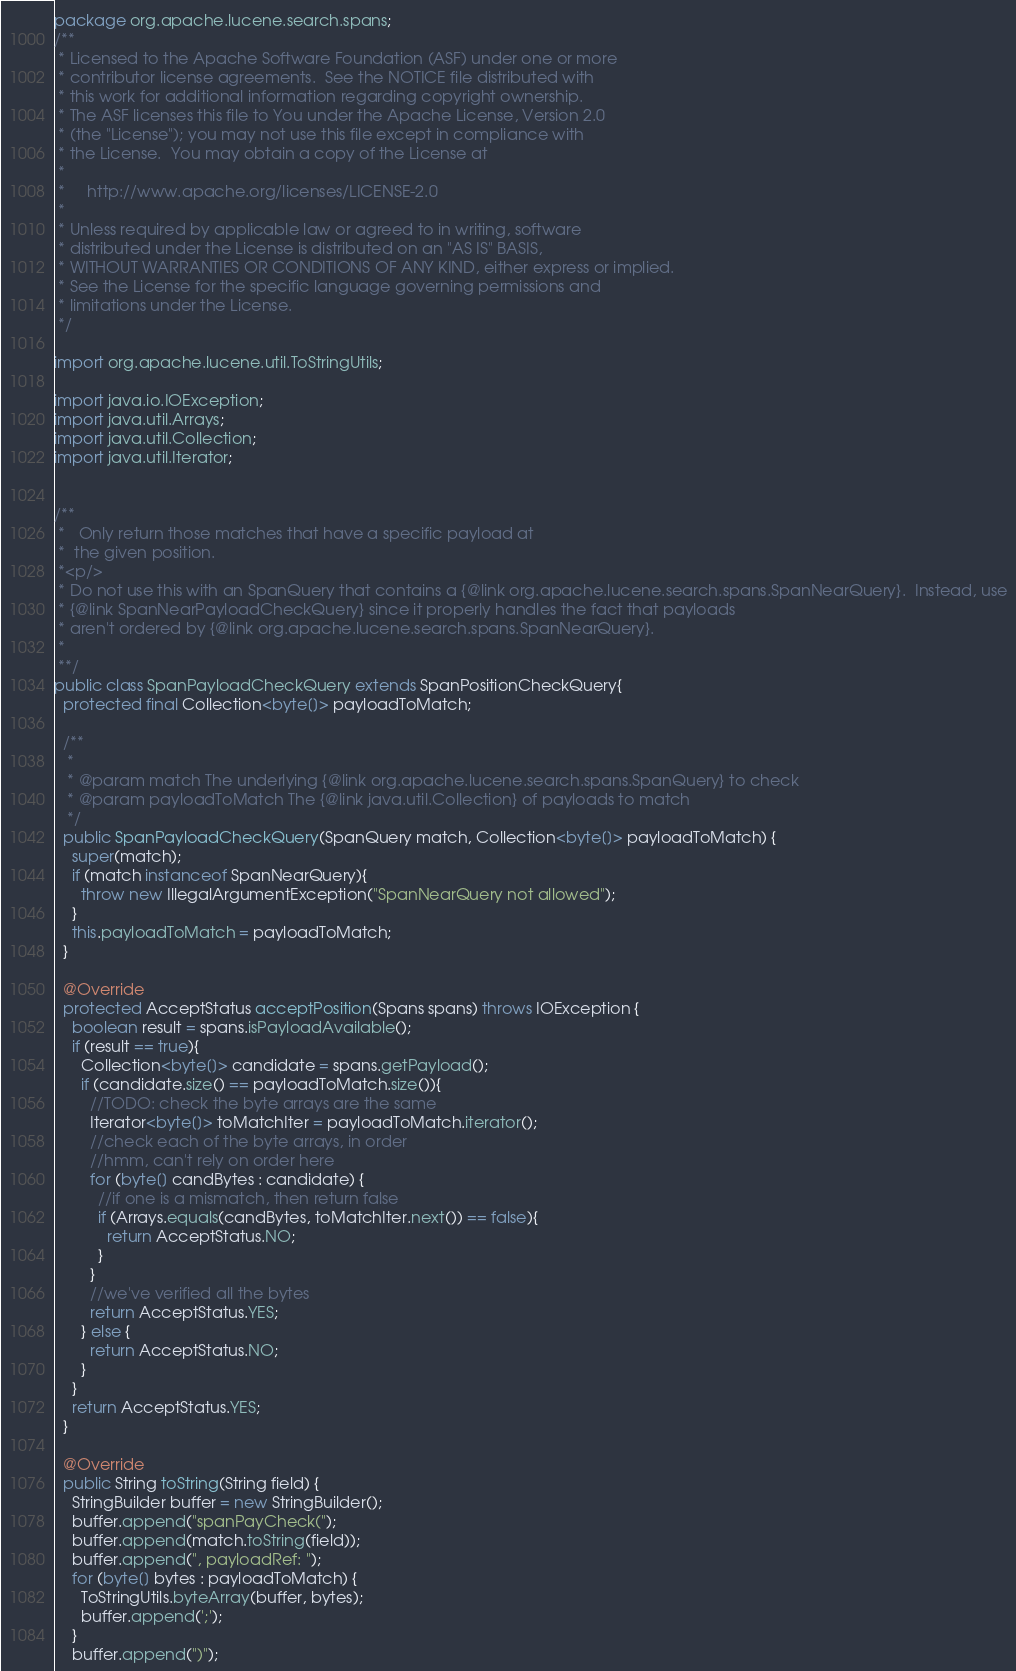<code> <loc_0><loc_0><loc_500><loc_500><_Java_>package org.apache.lucene.search.spans;
/**
 * Licensed to the Apache Software Foundation (ASF) under one or more
 * contributor license agreements.  See the NOTICE file distributed with
 * this work for additional information regarding copyright ownership.
 * The ASF licenses this file to You under the Apache License, Version 2.0
 * (the "License"); you may not use this file except in compliance with
 * the License.  You may obtain a copy of the License at
 *
 *     http://www.apache.org/licenses/LICENSE-2.0
 *
 * Unless required by applicable law or agreed to in writing, software
 * distributed under the License is distributed on an "AS IS" BASIS,
 * WITHOUT WARRANTIES OR CONDITIONS OF ANY KIND, either express or implied.
 * See the License for the specific language governing permissions and
 * limitations under the License.
 */

import org.apache.lucene.util.ToStringUtils;

import java.io.IOException;
import java.util.Arrays;
import java.util.Collection;
import java.util.Iterator;


/**
 *   Only return those matches that have a specific payload at
 *  the given position.
 *<p/>
 * Do not use this with an SpanQuery that contains a {@link org.apache.lucene.search.spans.SpanNearQuery}.  Instead, use
 * {@link SpanNearPayloadCheckQuery} since it properly handles the fact that payloads
 * aren't ordered by {@link org.apache.lucene.search.spans.SpanNearQuery}.
 *
 **/
public class SpanPayloadCheckQuery extends SpanPositionCheckQuery{
  protected final Collection<byte[]> payloadToMatch;

  /**
   *
   * @param match The underlying {@link org.apache.lucene.search.spans.SpanQuery} to check
   * @param payloadToMatch The {@link java.util.Collection} of payloads to match
   */
  public SpanPayloadCheckQuery(SpanQuery match, Collection<byte[]> payloadToMatch) {
    super(match);
    if (match instanceof SpanNearQuery){
      throw new IllegalArgumentException("SpanNearQuery not allowed");
    }
    this.payloadToMatch = payloadToMatch;
  }

  @Override
  protected AcceptStatus acceptPosition(Spans spans) throws IOException {
    boolean result = spans.isPayloadAvailable();
    if (result == true){
      Collection<byte[]> candidate = spans.getPayload();
      if (candidate.size() == payloadToMatch.size()){
        //TODO: check the byte arrays are the same
        Iterator<byte[]> toMatchIter = payloadToMatch.iterator();
        //check each of the byte arrays, in order
        //hmm, can't rely on order here
        for (byte[] candBytes : candidate) {
          //if one is a mismatch, then return false
          if (Arrays.equals(candBytes, toMatchIter.next()) == false){
            return AcceptStatus.NO;
          }
        }
        //we've verified all the bytes
        return AcceptStatus.YES;
      } else {
        return AcceptStatus.NO;
      }
    }
    return AcceptStatus.YES;
  } 

  @Override
  public String toString(String field) {
    StringBuilder buffer = new StringBuilder();
    buffer.append("spanPayCheck(");
    buffer.append(match.toString(field));
    buffer.append(", payloadRef: ");
    for (byte[] bytes : payloadToMatch) {
      ToStringUtils.byteArray(buffer, bytes);
      buffer.append(';');
    }
    buffer.append(")");</code> 